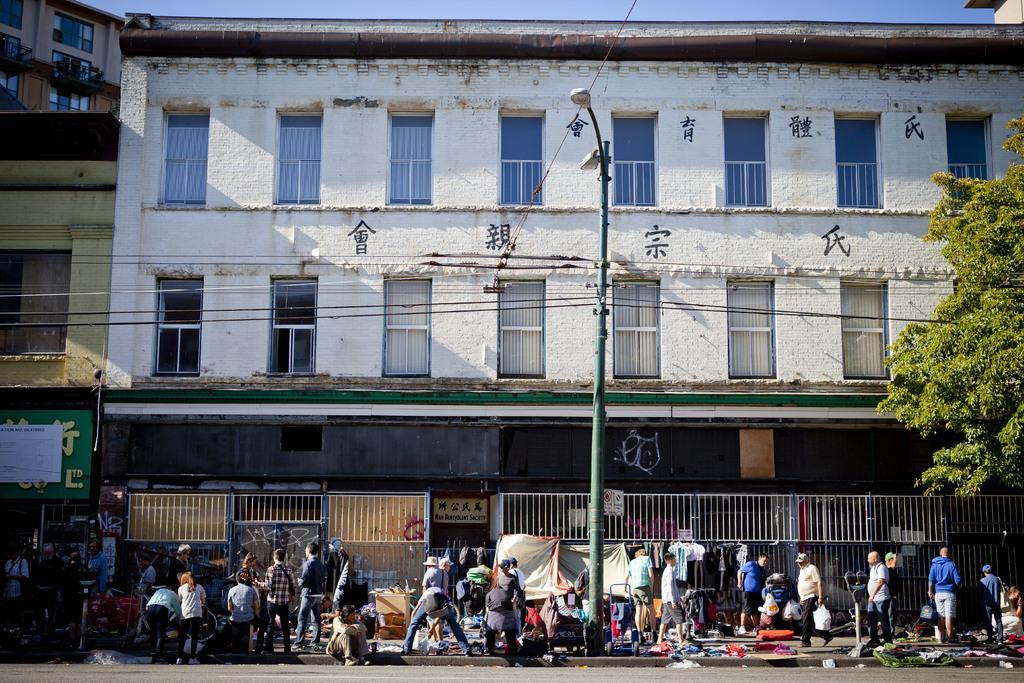Could you give a brief overview of what you see in this image? In this picture, we can see a few people, and a few are holding some objects, we can see the ground, pole, wires, trees, building with windows, and some text on it, we can see the sky. 